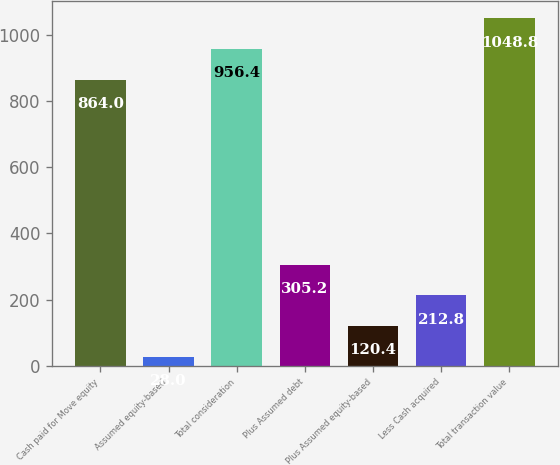<chart> <loc_0><loc_0><loc_500><loc_500><bar_chart><fcel>Cash paid for Move equity<fcel>Assumed equity-based<fcel>Total consideration<fcel>Plus Assumed debt<fcel>Plus Assumed equity-based<fcel>Less Cash acquired<fcel>Total transaction value<nl><fcel>864<fcel>28<fcel>956.4<fcel>305.2<fcel>120.4<fcel>212.8<fcel>1048.8<nl></chart> 